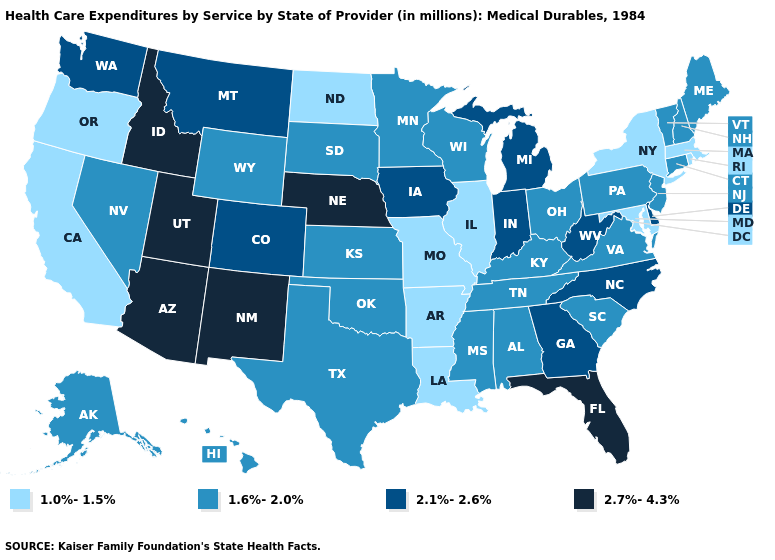What is the value of New Jersey?
Be succinct. 1.6%-2.0%. Does Hawaii have the highest value in the West?
Short answer required. No. What is the value of Alaska?
Be succinct. 1.6%-2.0%. Does New Mexico have the highest value in the USA?
Answer briefly. Yes. Which states hav the highest value in the MidWest?
Give a very brief answer. Nebraska. Does North Carolina have the same value as Georgia?
Answer briefly. Yes. How many symbols are there in the legend?
Be succinct. 4. Name the states that have a value in the range 2.7%-4.3%?
Quick response, please. Arizona, Florida, Idaho, Nebraska, New Mexico, Utah. What is the value of North Carolina?
Quick response, please. 2.1%-2.6%. Among the states that border West Virginia , which have the highest value?
Short answer required. Kentucky, Ohio, Pennsylvania, Virginia. Which states have the lowest value in the West?
Quick response, please. California, Oregon. What is the lowest value in the USA?
Write a very short answer. 1.0%-1.5%. Does Utah have the lowest value in the USA?
Write a very short answer. No. Name the states that have a value in the range 2.1%-2.6%?
Concise answer only. Colorado, Delaware, Georgia, Indiana, Iowa, Michigan, Montana, North Carolina, Washington, West Virginia. What is the value of Kentucky?
Give a very brief answer. 1.6%-2.0%. 